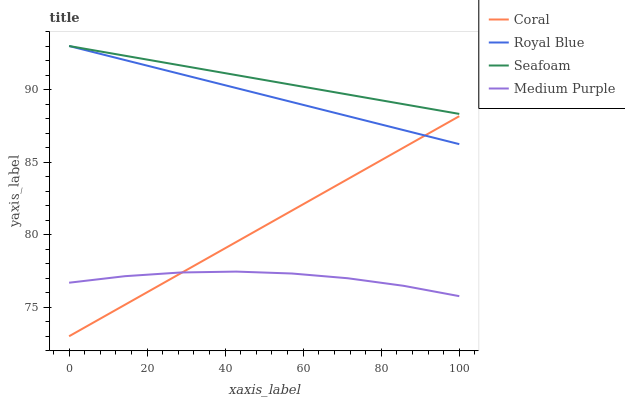Does Medium Purple have the minimum area under the curve?
Answer yes or no. Yes. Does Seafoam have the maximum area under the curve?
Answer yes or no. Yes. Does Royal Blue have the minimum area under the curve?
Answer yes or no. No. Does Royal Blue have the maximum area under the curve?
Answer yes or no. No. Is Coral the smoothest?
Answer yes or no. Yes. Is Medium Purple the roughest?
Answer yes or no. Yes. Is Royal Blue the smoothest?
Answer yes or no. No. Is Royal Blue the roughest?
Answer yes or no. No. Does Coral have the lowest value?
Answer yes or no. Yes. Does Royal Blue have the lowest value?
Answer yes or no. No. Does Seafoam have the highest value?
Answer yes or no. Yes. Does Coral have the highest value?
Answer yes or no. No. Is Medium Purple less than Seafoam?
Answer yes or no. Yes. Is Seafoam greater than Coral?
Answer yes or no. Yes. Does Coral intersect Royal Blue?
Answer yes or no. Yes. Is Coral less than Royal Blue?
Answer yes or no. No. Is Coral greater than Royal Blue?
Answer yes or no. No. Does Medium Purple intersect Seafoam?
Answer yes or no. No. 